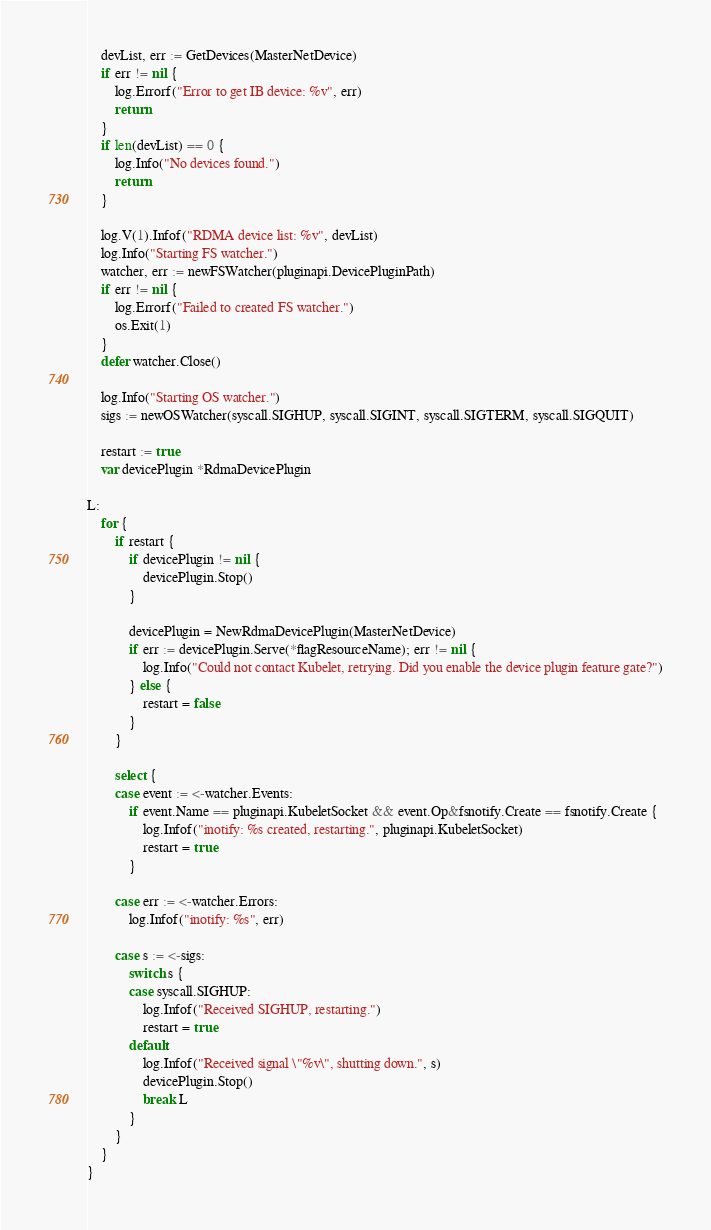Convert code to text. <code><loc_0><loc_0><loc_500><loc_500><_Go_>
	devList, err := GetDevices(MasterNetDevice)
	if err != nil {
		log.Errorf("Error to get IB device: %v", err)
		return
	}
	if len(devList) == 0 {
		log.Info("No devices found.")
		return
	}

	log.V(1).Infof("RDMA device list: %v", devList)
	log.Info("Starting FS watcher.")
	watcher, err := newFSWatcher(pluginapi.DevicePluginPath)
	if err != nil {
		log.Errorf("Failed to created FS watcher.")
		os.Exit(1)
	}
	defer watcher.Close()

	log.Info("Starting OS watcher.")
	sigs := newOSWatcher(syscall.SIGHUP, syscall.SIGINT, syscall.SIGTERM, syscall.SIGQUIT)

	restart := true
	var devicePlugin *RdmaDevicePlugin

L:
	for {
		if restart {
			if devicePlugin != nil {
				devicePlugin.Stop()
			}

			devicePlugin = NewRdmaDevicePlugin(MasterNetDevice)
			if err := devicePlugin.Serve(*flagResourceName); err != nil {
				log.Info("Could not contact Kubelet, retrying. Did you enable the device plugin feature gate?")
			} else {
				restart = false
			}
		}

		select {
		case event := <-watcher.Events:
			if event.Name == pluginapi.KubeletSocket && event.Op&fsnotify.Create == fsnotify.Create {
				log.Infof("inotify: %s created, restarting.", pluginapi.KubeletSocket)
				restart = true
			}

		case err := <-watcher.Errors:
			log.Infof("inotify: %s", err)

		case s := <-sigs:
			switch s {
			case syscall.SIGHUP:
				log.Infof("Received SIGHUP, restarting.")
				restart = true
			default:
				log.Infof("Received signal \"%v\", shutting down.", s)
				devicePlugin.Stop()
				break L
			}
		}
	}
}
</code> 